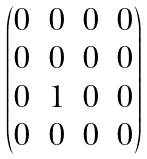Convert formula to latex. <formula><loc_0><loc_0><loc_500><loc_500>\begin{pmatrix} 0 & 0 & 0 & 0 \\ 0 & 0 & 0 & 0 \\ 0 & 1 & 0 & 0 \\ 0 & 0 & 0 & 0 \end{pmatrix}</formula> 